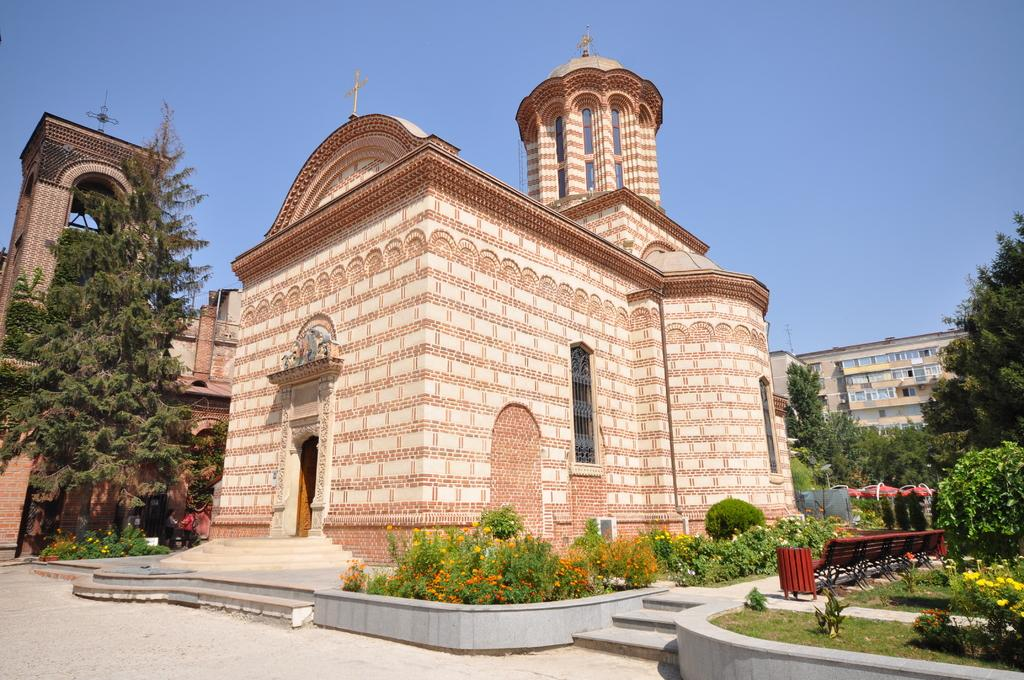What is the main subject in the center of the image? There is a monument in the center of the image. What type of vegetation can be seen in the image? There are flower plants and trees in the image. What type of structures are visible in the image? There are buildings in the image. What is the price of the soup served at the monument in the image? There is no soup or price mentioned in the image; it only features a monument, flower plants, trees, and buildings. 